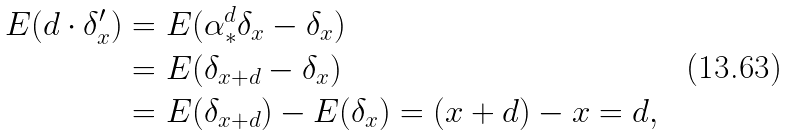<formula> <loc_0><loc_0><loc_500><loc_500>E ( d \cdot \delta _ { x } ^ { \prime } ) & = E ( \alpha ^ { d } _ { * } \delta _ { x } - \delta _ { x } ) \\ & = E ( \delta _ { x + d } - \delta _ { x } ) \\ & = E ( \delta _ { x + d } ) - E ( \delta _ { x } ) = ( x + d ) - x = d ,</formula> 